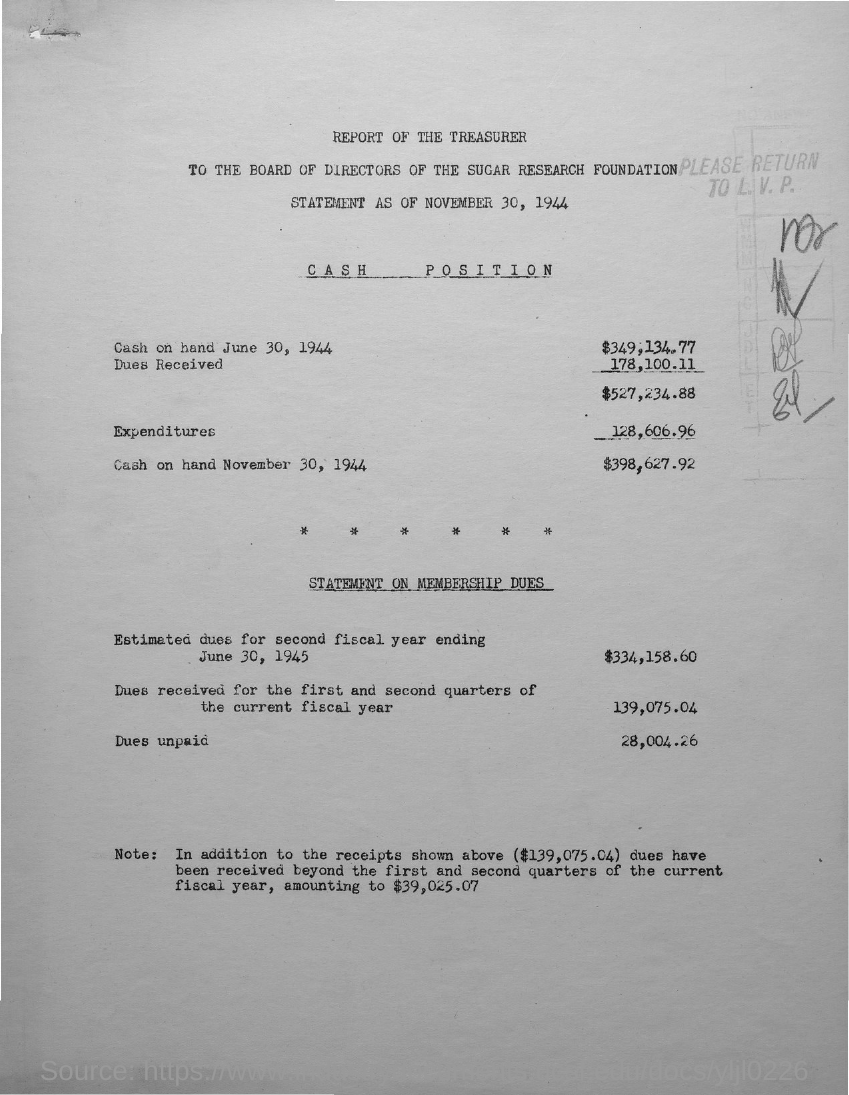Give some essential details in this illustration. The first title with an underline is "Cash Position..". 